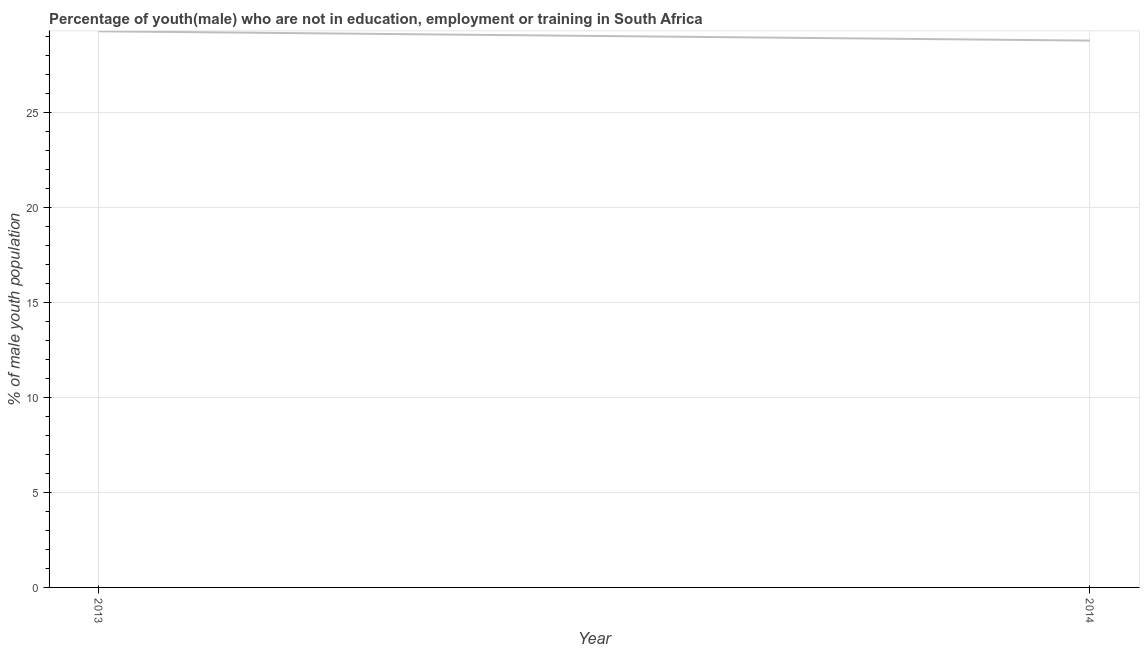What is the unemployed male youth population in 2014?
Your response must be concise. 28.77. Across all years, what is the maximum unemployed male youth population?
Offer a terse response. 29.26. Across all years, what is the minimum unemployed male youth population?
Make the answer very short. 28.77. What is the sum of the unemployed male youth population?
Provide a succinct answer. 58.03. What is the difference between the unemployed male youth population in 2013 and 2014?
Your answer should be compact. 0.49. What is the average unemployed male youth population per year?
Your answer should be compact. 29.02. What is the median unemployed male youth population?
Offer a very short reply. 29.02. What is the ratio of the unemployed male youth population in 2013 to that in 2014?
Provide a succinct answer. 1.02. Is the unemployed male youth population in 2013 less than that in 2014?
Give a very brief answer. No. Does the unemployed male youth population monotonically increase over the years?
Offer a very short reply. No. How many lines are there?
Your answer should be very brief. 1. What is the difference between two consecutive major ticks on the Y-axis?
Your answer should be very brief. 5. Are the values on the major ticks of Y-axis written in scientific E-notation?
Offer a very short reply. No. Does the graph contain any zero values?
Offer a terse response. No. Does the graph contain grids?
Keep it short and to the point. Yes. What is the title of the graph?
Give a very brief answer. Percentage of youth(male) who are not in education, employment or training in South Africa. What is the label or title of the Y-axis?
Your answer should be compact. % of male youth population. What is the % of male youth population of 2013?
Your answer should be compact. 29.26. What is the % of male youth population in 2014?
Your answer should be compact. 28.77. What is the difference between the % of male youth population in 2013 and 2014?
Make the answer very short. 0.49. 